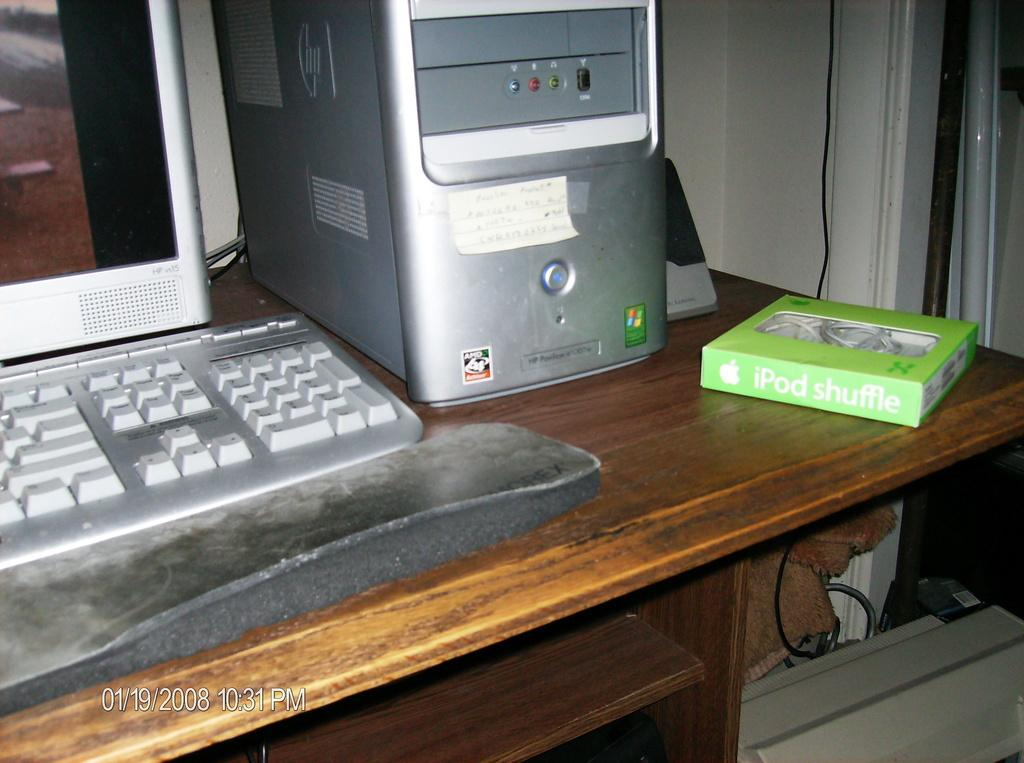<image>
Describe the image concisely. An iPod Shuffle sits on a desk along with a computer and keyboard. 